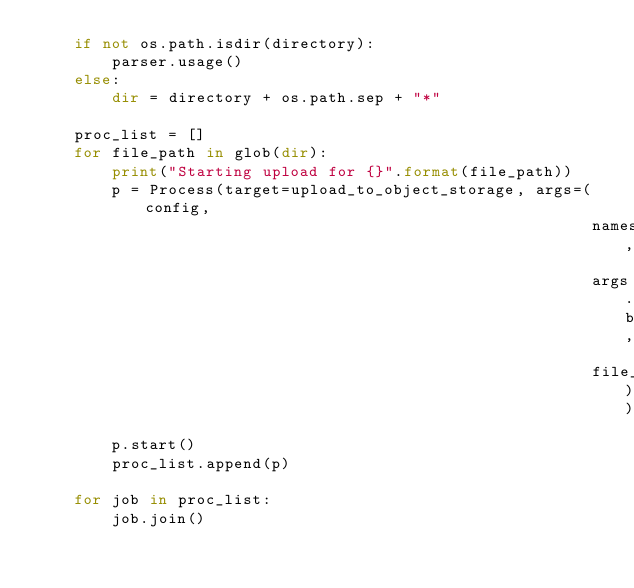Convert code to text. <code><loc_0><loc_0><loc_500><loc_500><_Python_>    if not os.path.isdir(directory):
        parser.usage()
    else:
        dir = directory + os.path.sep + "*"

    proc_list = []
    for file_path in glob(dir):
        print("Starting upload for {}".format(file_path))
        p = Process(target=upload_to_object_storage, args=(config,
                                                           namespace,
                                                           args.bucket_name,
                                                           file_path))
        p.start()
        proc_list.append(p)

    for job in proc_list:
        job.join()
</code> 